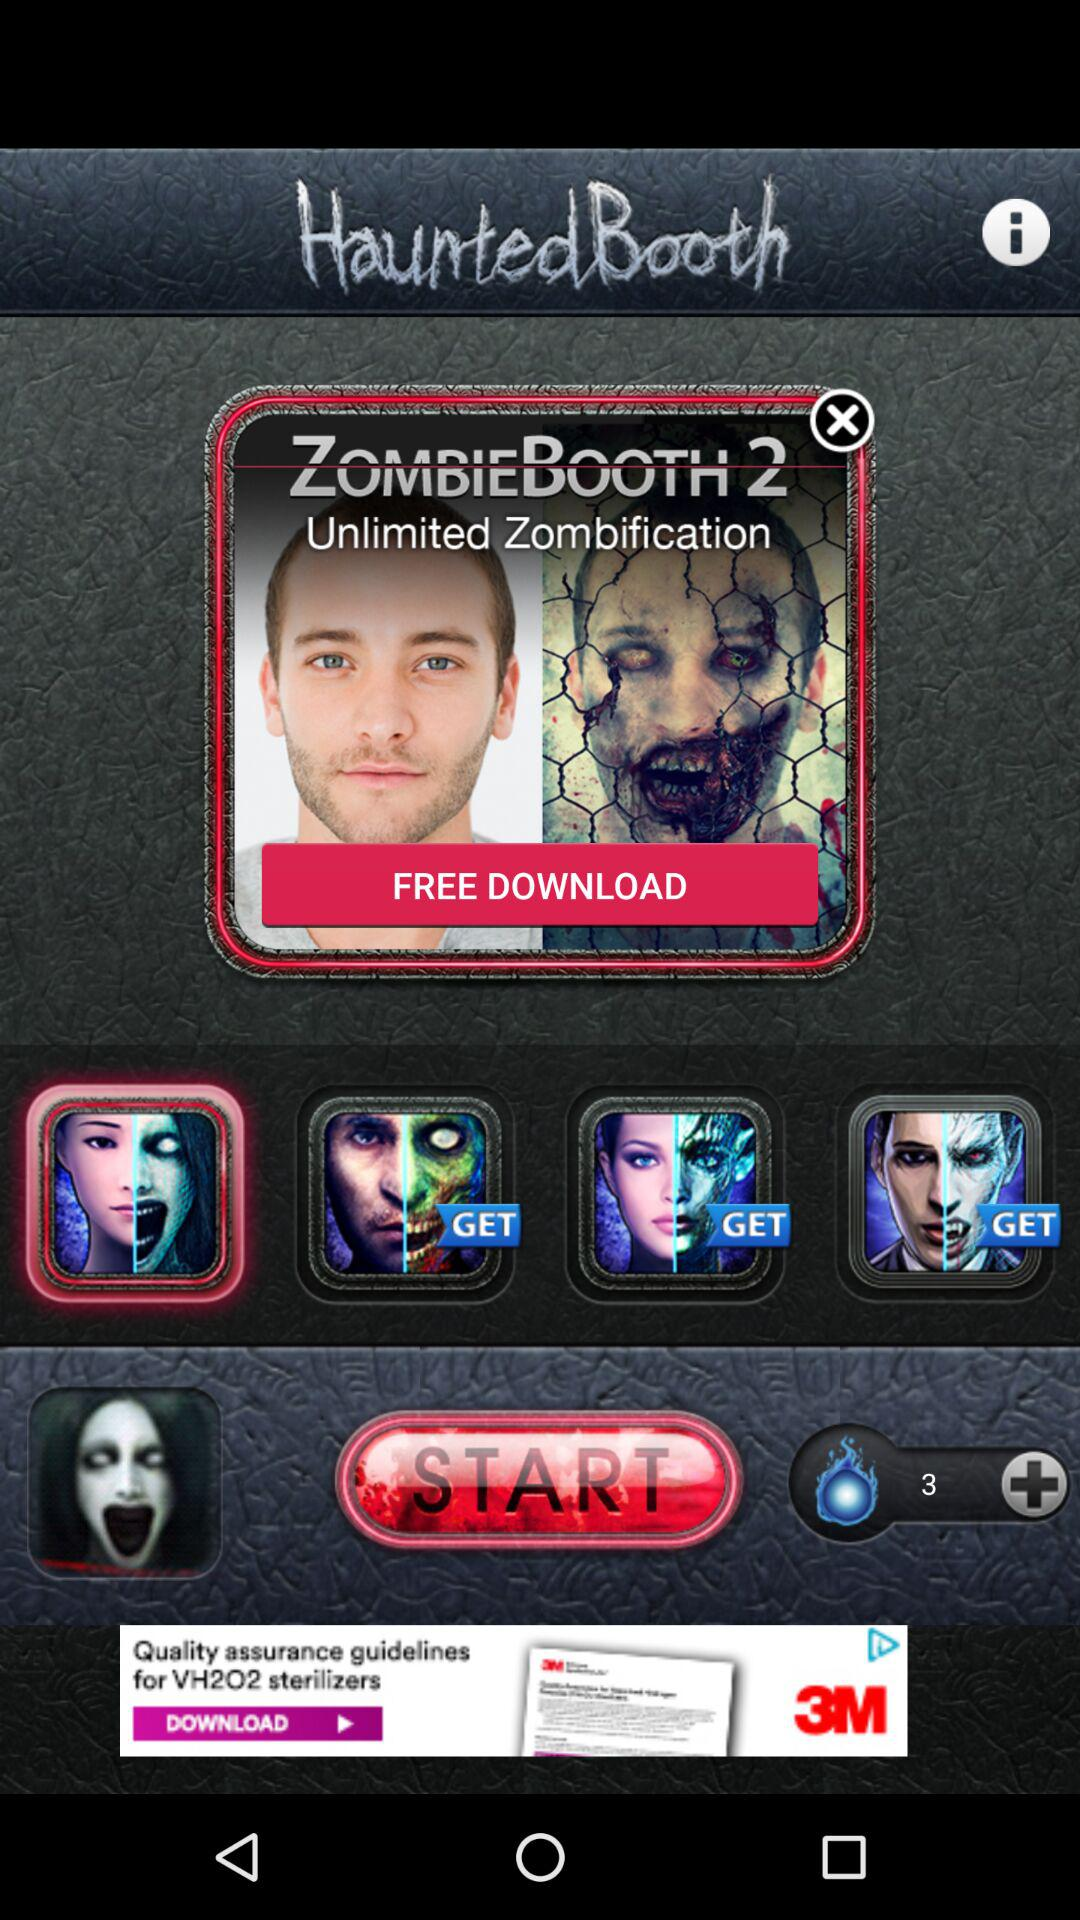What is the application name? The application name is "Haunted Booth". 